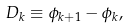Convert formula to latex. <formula><loc_0><loc_0><loc_500><loc_500>D _ { k } \equiv \phi _ { k + 1 } - \phi _ { k } ,</formula> 